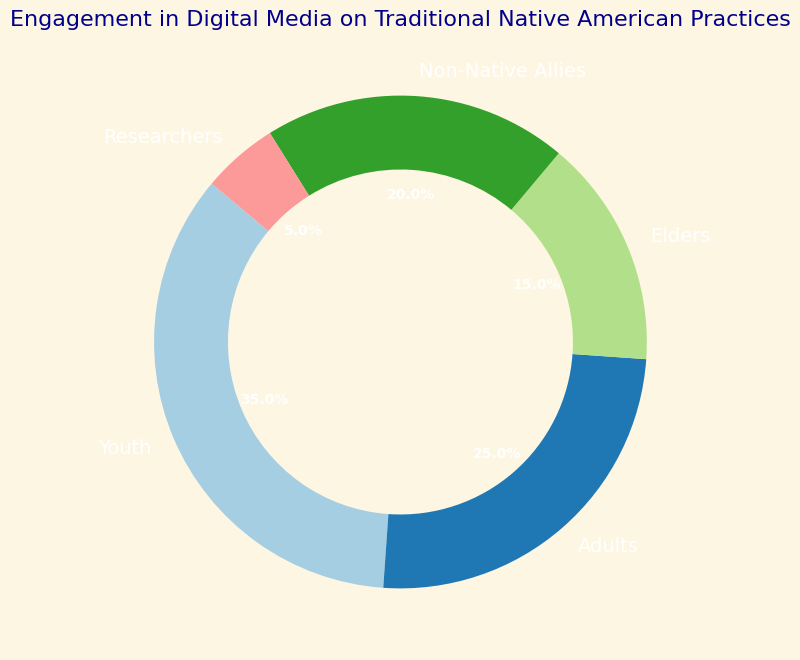What is the primary audience engaging with digital media on traditional Native American practices? The largest segment of the pie chart represents the primary audience. The size of each segment is proportional to the percentage of that audience. By observing, we see that the 'Youth' segment is the largest with 35%.
Answer: Youth Which two audiences have the smallest engagement percentages? The pie chart displays different audience segments and their corresponding percentages. By identifying the segments with the smallest numerical values, we find that 'Researchers' with 5% and 'Elders' with 15% are the smallest.
Answer: Researchers and Elders By how much does the engagement percentage of youth exceed the engagement percentage of adults? To find the difference, we subtract the percentage of adults from the percentage of youth. The youth percentage is 35%, and the adults' percentage is 25%. So, 35% - 25% = 10%.
Answer: 10% Which color represents the 'Non-Native Allies' audience in the pie chart? Observing the chart legend or the color-coded segments, we see that each segment corresponds to a different color. The 'Non-Native Allies' is represented by a specific color which can be identified visually. Suppose it is visually green.
Answer: Green What is the combined engagement percentage of 'Elders' and 'Non-Native Allies'? The pie chart shows percentages for different groups. To find the combined engagement percentage of 'Elders' and 'Non-Native Allies', we sum their individual percentages. 15% + 20% = 35%.
Answer: 35% Rank the audiences from highest to lowest in terms of engagement on digital media about traditional practices. By comparing the sizes of the segments and their percentages in the pie chart, we can rank the audiences. From highest to lowest, the rankings are: Youth (35%), Adults (25%), Non-Native Allies (20%), Elders (15%), Researchers (5%).
Answer: Youth, Adults, Non-Native Allies, Elders, Researchers By what factor is the engagement percentage of non-Native allies greater than that of researchers? To determine the factor, we divide the percentage of non-Native allies by that of researchers. The non-Native allies percentage is 20% and the researchers' percentage is 5%. So, 20% / 5% = 4.
Answer: 4 What is the second most engaged audience? From the pie chart, the second largest segment represents the second most engaged audience, which is 'Adults' with a 25% engagement rate.
Answer: Adults 